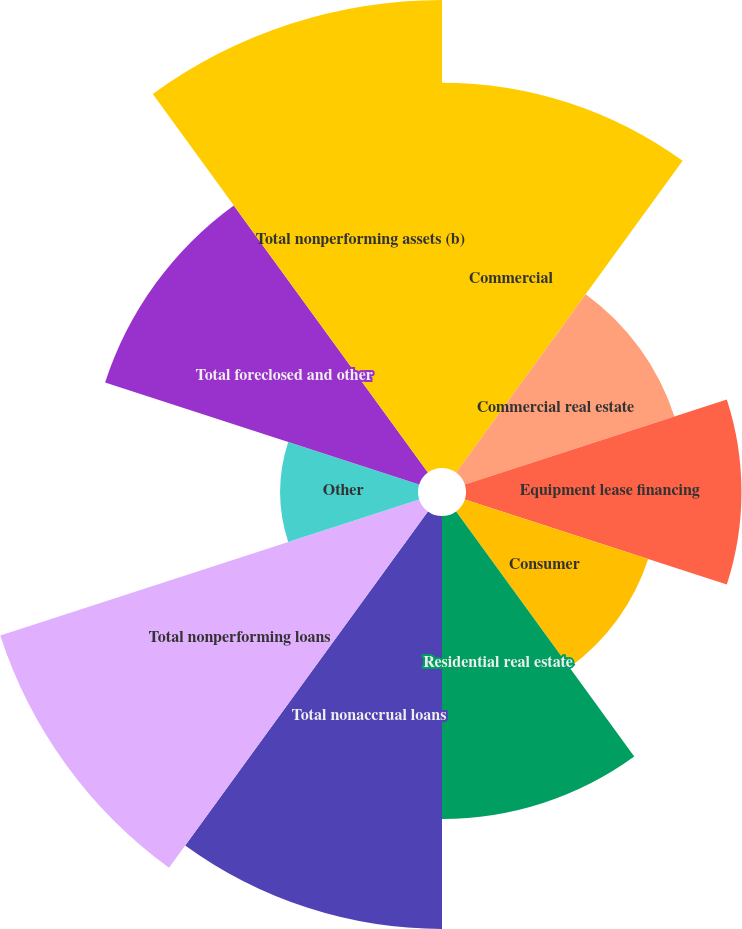<chart> <loc_0><loc_0><loc_500><loc_500><pie_chart><fcel>Commercial<fcel>Commercial real estate<fcel>Equipment lease financing<fcel>Consumer<fcel>Residential real estate<fcel>Total nonaccrual loans<fcel>Total nonperforming loans<fcel>Other<fcel>Total foreclosed and other<fcel>Total nonperforming assets (b)<nl><fcel>12.17%<fcel>6.96%<fcel>8.7%<fcel>6.09%<fcel>9.57%<fcel>13.04%<fcel>13.91%<fcel>4.35%<fcel>10.43%<fcel>14.78%<nl></chart> 